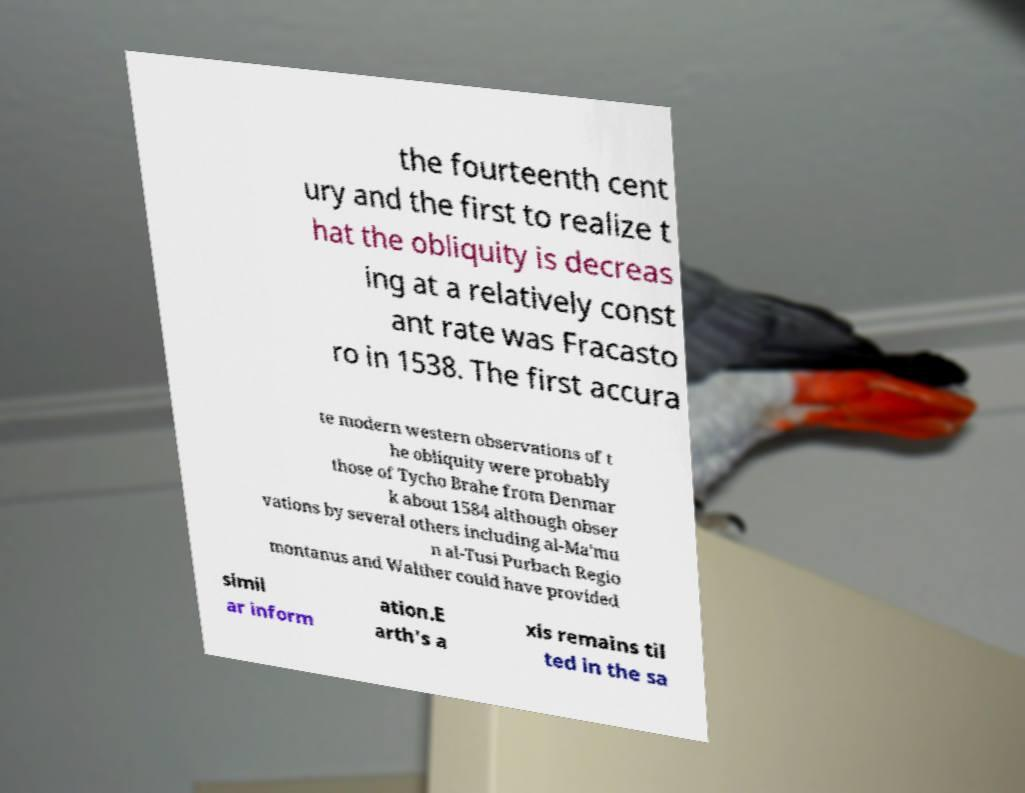Could you assist in decoding the text presented in this image and type it out clearly? the fourteenth cent ury and the first to realize t hat the obliquity is decreas ing at a relatively const ant rate was Fracasto ro in 1538. The first accura te modern western observations of t he obliquity were probably those of Tycho Brahe from Denmar k about 1584 although obser vations by several others including al-Ma'mu n al-Tusi Purbach Regio montanus and Walther could have provided simil ar inform ation.E arth's a xis remains til ted in the sa 